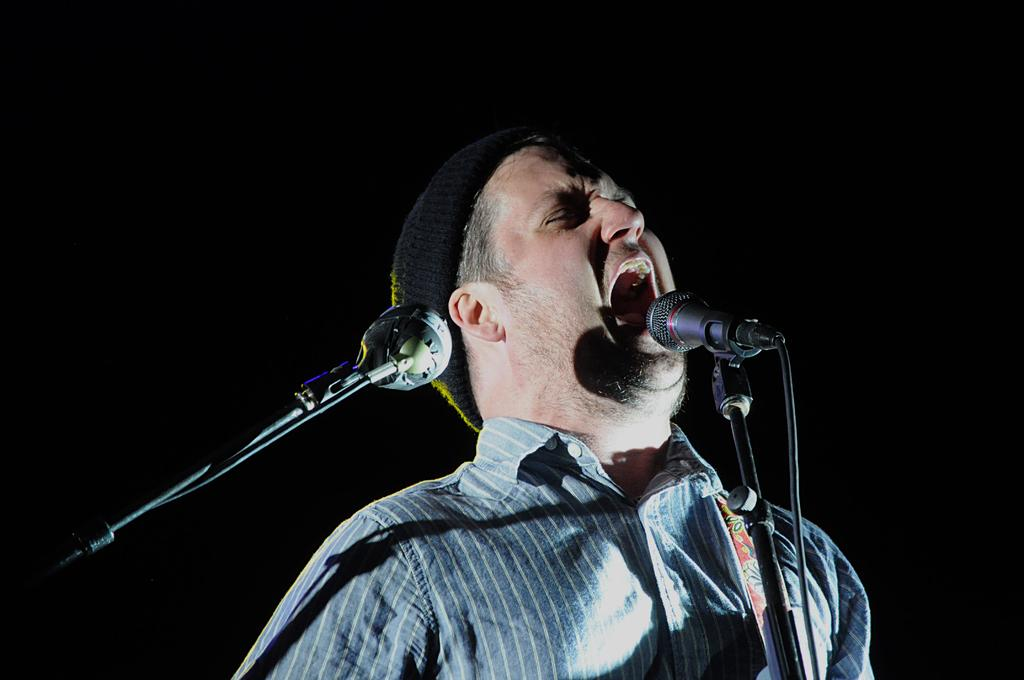What is the person in the image doing? The person is singing in the image. How is the person amplifying their voice? The person is using a microphone. What color is the background of the image? The background of the image is black. Are there any other microphones visible in the image? Yes, there is another microphone on the left side of the image. What type of crops can be seen growing in the field in the image? There is no field or crops present in the image; it features a person singing with a microphone against a black background. 